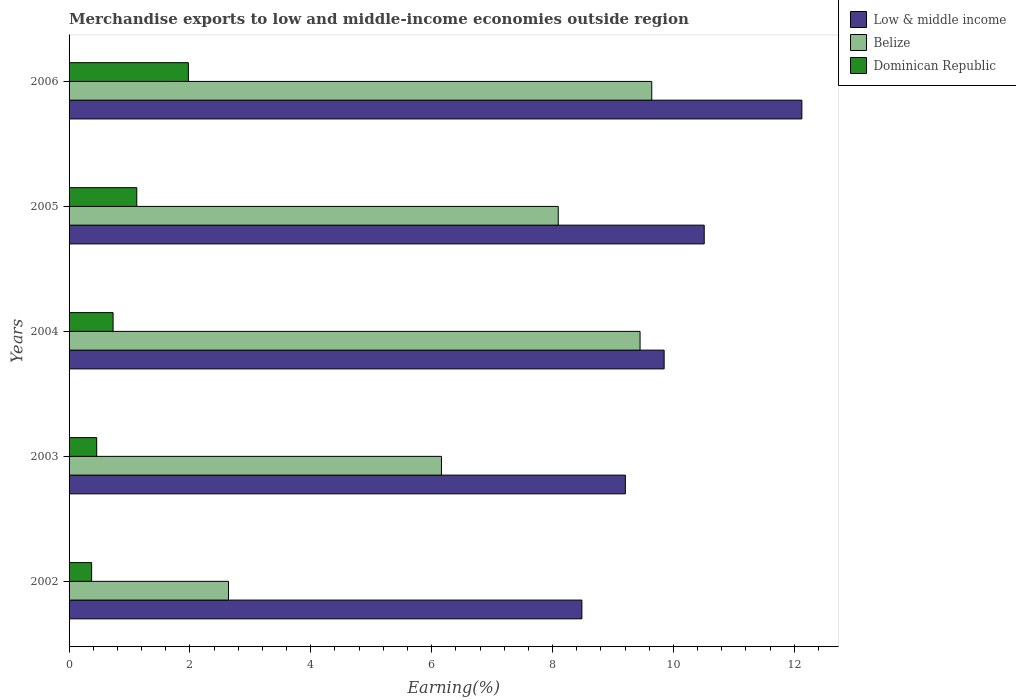Are the number of bars on each tick of the Y-axis equal?
Your answer should be very brief. Yes. How many bars are there on the 4th tick from the bottom?
Your answer should be very brief. 3. What is the label of the 3rd group of bars from the top?
Your answer should be very brief. 2004. In how many cases, is the number of bars for a given year not equal to the number of legend labels?
Keep it short and to the point. 0. What is the percentage of amount earned from merchandise exports in Belize in 2004?
Your response must be concise. 9.45. Across all years, what is the maximum percentage of amount earned from merchandise exports in Belize?
Your answer should be very brief. 9.64. Across all years, what is the minimum percentage of amount earned from merchandise exports in Low & middle income?
Ensure brevity in your answer.  8.49. In which year was the percentage of amount earned from merchandise exports in Dominican Republic maximum?
Provide a short and direct response. 2006. In which year was the percentage of amount earned from merchandise exports in Dominican Republic minimum?
Provide a succinct answer. 2002. What is the total percentage of amount earned from merchandise exports in Low & middle income in the graph?
Keep it short and to the point. 50.17. What is the difference between the percentage of amount earned from merchandise exports in Low & middle income in 2002 and that in 2006?
Offer a very short reply. -3.64. What is the difference between the percentage of amount earned from merchandise exports in Low & middle income in 2006 and the percentage of amount earned from merchandise exports in Dominican Republic in 2002?
Ensure brevity in your answer.  11.75. What is the average percentage of amount earned from merchandise exports in Dominican Republic per year?
Make the answer very short. 0.93. In the year 2005, what is the difference between the percentage of amount earned from merchandise exports in Low & middle income and percentage of amount earned from merchandise exports in Dominican Republic?
Provide a short and direct response. 9.39. In how many years, is the percentage of amount earned from merchandise exports in Belize greater than 9.6 %?
Ensure brevity in your answer.  1. What is the ratio of the percentage of amount earned from merchandise exports in Dominican Republic in 2005 to that in 2006?
Your response must be concise. 0.57. What is the difference between the highest and the second highest percentage of amount earned from merchandise exports in Dominican Republic?
Offer a very short reply. 0.85. What is the difference between the highest and the lowest percentage of amount earned from merchandise exports in Dominican Republic?
Offer a terse response. 1.6. What does the 1st bar from the top in 2003 represents?
Your response must be concise. Dominican Republic. What does the 3rd bar from the bottom in 2002 represents?
Provide a succinct answer. Dominican Republic. How many bars are there?
Provide a succinct answer. 15. How many years are there in the graph?
Offer a very short reply. 5. What is the difference between two consecutive major ticks on the X-axis?
Your response must be concise. 2. Does the graph contain grids?
Your answer should be very brief. No. How are the legend labels stacked?
Give a very brief answer. Vertical. What is the title of the graph?
Your answer should be compact. Merchandise exports to low and middle-income economies outside region. What is the label or title of the X-axis?
Your answer should be very brief. Earning(%). What is the label or title of the Y-axis?
Provide a short and direct response. Years. What is the Earning(%) of Low & middle income in 2002?
Offer a very short reply. 8.49. What is the Earning(%) in Belize in 2002?
Offer a very short reply. 2.64. What is the Earning(%) of Dominican Republic in 2002?
Your answer should be very brief. 0.37. What is the Earning(%) in Low & middle income in 2003?
Make the answer very short. 9.2. What is the Earning(%) in Belize in 2003?
Your answer should be very brief. 6.16. What is the Earning(%) of Dominican Republic in 2003?
Make the answer very short. 0.46. What is the Earning(%) in Low & middle income in 2004?
Your answer should be very brief. 9.85. What is the Earning(%) of Belize in 2004?
Your response must be concise. 9.45. What is the Earning(%) in Dominican Republic in 2004?
Make the answer very short. 0.73. What is the Earning(%) of Low & middle income in 2005?
Ensure brevity in your answer.  10.51. What is the Earning(%) in Belize in 2005?
Provide a short and direct response. 8.09. What is the Earning(%) of Dominican Republic in 2005?
Give a very brief answer. 1.12. What is the Earning(%) of Low & middle income in 2006?
Your answer should be very brief. 12.13. What is the Earning(%) in Belize in 2006?
Keep it short and to the point. 9.64. What is the Earning(%) in Dominican Republic in 2006?
Offer a terse response. 1.97. Across all years, what is the maximum Earning(%) in Low & middle income?
Your response must be concise. 12.13. Across all years, what is the maximum Earning(%) in Belize?
Ensure brevity in your answer.  9.64. Across all years, what is the maximum Earning(%) in Dominican Republic?
Provide a succinct answer. 1.97. Across all years, what is the minimum Earning(%) in Low & middle income?
Keep it short and to the point. 8.49. Across all years, what is the minimum Earning(%) of Belize?
Provide a succinct answer. 2.64. Across all years, what is the minimum Earning(%) in Dominican Republic?
Give a very brief answer. 0.37. What is the total Earning(%) of Low & middle income in the graph?
Ensure brevity in your answer.  50.17. What is the total Earning(%) of Belize in the graph?
Offer a terse response. 35.98. What is the total Earning(%) in Dominican Republic in the graph?
Give a very brief answer. 4.65. What is the difference between the Earning(%) of Low & middle income in 2002 and that in 2003?
Give a very brief answer. -0.72. What is the difference between the Earning(%) in Belize in 2002 and that in 2003?
Offer a very short reply. -3.52. What is the difference between the Earning(%) in Dominican Republic in 2002 and that in 2003?
Your answer should be compact. -0.08. What is the difference between the Earning(%) in Low & middle income in 2002 and that in 2004?
Keep it short and to the point. -1.36. What is the difference between the Earning(%) in Belize in 2002 and that in 2004?
Make the answer very short. -6.81. What is the difference between the Earning(%) of Dominican Republic in 2002 and that in 2004?
Your answer should be compact. -0.35. What is the difference between the Earning(%) in Low & middle income in 2002 and that in 2005?
Provide a short and direct response. -2.02. What is the difference between the Earning(%) in Belize in 2002 and that in 2005?
Make the answer very short. -5.46. What is the difference between the Earning(%) in Dominican Republic in 2002 and that in 2005?
Make the answer very short. -0.75. What is the difference between the Earning(%) in Low & middle income in 2002 and that in 2006?
Your answer should be very brief. -3.64. What is the difference between the Earning(%) in Belize in 2002 and that in 2006?
Provide a short and direct response. -7. What is the difference between the Earning(%) in Dominican Republic in 2002 and that in 2006?
Make the answer very short. -1.6. What is the difference between the Earning(%) in Low & middle income in 2003 and that in 2004?
Ensure brevity in your answer.  -0.64. What is the difference between the Earning(%) of Belize in 2003 and that in 2004?
Make the answer very short. -3.29. What is the difference between the Earning(%) of Dominican Republic in 2003 and that in 2004?
Offer a terse response. -0.27. What is the difference between the Earning(%) in Low & middle income in 2003 and that in 2005?
Give a very brief answer. -1.3. What is the difference between the Earning(%) in Belize in 2003 and that in 2005?
Offer a very short reply. -1.93. What is the difference between the Earning(%) of Dominican Republic in 2003 and that in 2005?
Make the answer very short. -0.66. What is the difference between the Earning(%) of Low & middle income in 2003 and that in 2006?
Offer a terse response. -2.92. What is the difference between the Earning(%) in Belize in 2003 and that in 2006?
Provide a succinct answer. -3.48. What is the difference between the Earning(%) of Dominican Republic in 2003 and that in 2006?
Give a very brief answer. -1.52. What is the difference between the Earning(%) of Low & middle income in 2004 and that in 2005?
Ensure brevity in your answer.  -0.66. What is the difference between the Earning(%) of Belize in 2004 and that in 2005?
Offer a very short reply. 1.35. What is the difference between the Earning(%) of Dominican Republic in 2004 and that in 2005?
Offer a terse response. -0.39. What is the difference between the Earning(%) of Low & middle income in 2004 and that in 2006?
Offer a very short reply. -2.28. What is the difference between the Earning(%) of Belize in 2004 and that in 2006?
Give a very brief answer. -0.19. What is the difference between the Earning(%) in Dominican Republic in 2004 and that in 2006?
Make the answer very short. -1.25. What is the difference between the Earning(%) in Low & middle income in 2005 and that in 2006?
Keep it short and to the point. -1.62. What is the difference between the Earning(%) in Belize in 2005 and that in 2006?
Offer a very short reply. -1.55. What is the difference between the Earning(%) of Dominican Republic in 2005 and that in 2006?
Give a very brief answer. -0.85. What is the difference between the Earning(%) in Low & middle income in 2002 and the Earning(%) in Belize in 2003?
Your answer should be very brief. 2.32. What is the difference between the Earning(%) of Low & middle income in 2002 and the Earning(%) of Dominican Republic in 2003?
Provide a short and direct response. 8.03. What is the difference between the Earning(%) of Belize in 2002 and the Earning(%) of Dominican Republic in 2003?
Offer a very short reply. 2.18. What is the difference between the Earning(%) of Low & middle income in 2002 and the Earning(%) of Belize in 2004?
Make the answer very short. -0.96. What is the difference between the Earning(%) in Low & middle income in 2002 and the Earning(%) in Dominican Republic in 2004?
Your answer should be compact. 7.76. What is the difference between the Earning(%) in Belize in 2002 and the Earning(%) in Dominican Republic in 2004?
Your response must be concise. 1.91. What is the difference between the Earning(%) in Low & middle income in 2002 and the Earning(%) in Belize in 2005?
Keep it short and to the point. 0.39. What is the difference between the Earning(%) of Low & middle income in 2002 and the Earning(%) of Dominican Republic in 2005?
Your answer should be very brief. 7.37. What is the difference between the Earning(%) in Belize in 2002 and the Earning(%) in Dominican Republic in 2005?
Keep it short and to the point. 1.52. What is the difference between the Earning(%) of Low & middle income in 2002 and the Earning(%) of Belize in 2006?
Ensure brevity in your answer.  -1.16. What is the difference between the Earning(%) of Low & middle income in 2002 and the Earning(%) of Dominican Republic in 2006?
Make the answer very short. 6.51. What is the difference between the Earning(%) of Belize in 2002 and the Earning(%) of Dominican Republic in 2006?
Ensure brevity in your answer.  0.66. What is the difference between the Earning(%) in Low & middle income in 2003 and the Earning(%) in Belize in 2004?
Your response must be concise. -0.24. What is the difference between the Earning(%) of Low & middle income in 2003 and the Earning(%) of Dominican Republic in 2004?
Provide a short and direct response. 8.48. What is the difference between the Earning(%) of Belize in 2003 and the Earning(%) of Dominican Republic in 2004?
Offer a very short reply. 5.43. What is the difference between the Earning(%) of Low & middle income in 2003 and the Earning(%) of Belize in 2005?
Your answer should be very brief. 1.11. What is the difference between the Earning(%) in Low & middle income in 2003 and the Earning(%) in Dominican Republic in 2005?
Your answer should be compact. 8.08. What is the difference between the Earning(%) of Belize in 2003 and the Earning(%) of Dominican Republic in 2005?
Your response must be concise. 5.04. What is the difference between the Earning(%) in Low & middle income in 2003 and the Earning(%) in Belize in 2006?
Ensure brevity in your answer.  -0.44. What is the difference between the Earning(%) in Low & middle income in 2003 and the Earning(%) in Dominican Republic in 2006?
Make the answer very short. 7.23. What is the difference between the Earning(%) in Belize in 2003 and the Earning(%) in Dominican Republic in 2006?
Give a very brief answer. 4.19. What is the difference between the Earning(%) in Low & middle income in 2004 and the Earning(%) in Belize in 2005?
Keep it short and to the point. 1.75. What is the difference between the Earning(%) in Low & middle income in 2004 and the Earning(%) in Dominican Republic in 2005?
Make the answer very short. 8.73. What is the difference between the Earning(%) of Belize in 2004 and the Earning(%) of Dominican Republic in 2005?
Your answer should be compact. 8.33. What is the difference between the Earning(%) in Low & middle income in 2004 and the Earning(%) in Belize in 2006?
Your answer should be very brief. 0.2. What is the difference between the Earning(%) of Low & middle income in 2004 and the Earning(%) of Dominican Republic in 2006?
Provide a short and direct response. 7.87. What is the difference between the Earning(%) of Belize in 2004 and the Earning(%) of Dominican Republic in 2006?
Provide a short and direct response. 7.47. What is the difference between the Earning(%) of Low & middle income in 2005 and the Earning(%) of Belize in 2006?
Offer a terse response. 0.87. What is the difference between the Earning(%) in Low & middle income in 2005 and the Earning(%) in Dominican Republic in 2006?
Ensure brevity in your answer.  8.54. What is the difference between the Earning(%) of Belize in 2005 and the Earning(%) of Dominican Republic in 2006?
Ensure brevity in your answer.  6.12. What is the average Earning(%) in Low & middle income per year?
Keep it short and to the point. 10.03. What is the average Earning(%) of Belize per year?
Offer a very short reply. 7.2. What is the average Earning(%) of Dominican Republic per year?
Make the answer very short. 0.93. In the year 2002, what is the difference between the Earning(%) in Low & middle income and Earning(%) in Belize?
Provide a succinct answer. 5.85. In the year 2002, what is the difference between the Earning(%) in Low & middle income and Earning(%) in Dominican Republic?
Give a very brief answer. 8.11. In the year 2002, what is the difference between the Earning(%) in Belize and Earning(%) in Dominican Republic?
Your answer should be compact. 2.26. In the year 2003, what is the difference between the Earning(%) in Low & middle income and Earning(%) in Belize?
Offer a very short reply. 3.04. In the year 2003, what is the difference between the Earning(%) in Low & middle income and Earning(%) in Dominican Republic?
Give a very brief answer. 8.75. In the year 2003, what is the difference between the Earning(%) in Belize and Earning(%) in Dominican Republic?
Make the answer very short. 5.7. In the year 2004, what is the difference between the Earning(%) of Low & middle income and Earning(%) of Belize?
Give a very brief answer. 0.4. In the year 2004, what is the difference between the Earning(%) of Low & middle income and Earning(%) of Dominican Republic?
Ensure brevity in your answer.  9.12. In the year 2004, what is the difference between the Earning(%) in Belize and Earning(%) in Dominican Republic?
Ensure brevity in your answer.  8.72. In the year 2005, what is the difference between the Earning(%) in Low & middle income and Earning(%) in Belize?
Keep it short and to the point. 2.42. In the year 2005, what is the difference between the Earning(%) in Low & middle income and Earning(%) in Dominican Republic?
Your answer should be very brief. 9.39. In the year 2005, what is the difference between the Earning(%) in Belize and Earning(%) in Dominican Republic?
Keep it short and to the point. 6.97. In the year 2006, what is the difference between the Earning(%) in Low & middle income and Earning(%) in Belize?
Ensure brevity in your answer.  2.48. In the year 2006, what is the difference between the Earning(%) of Low & middle income and Earning(%) of Dominican Republic?
Keep it short and to the point. 10.15. In the year 2006, what is the difference between the Earning(%) of Belize and Earning(%) of Dominican Republic?
Your answer should be compact. 7.67. What is the ratio of the Earning(%) of Low & middle income in 2002 to that in 2003?
Your answer should be very brief. 0.92. What is the ratio of the Earning(%) of Belize in 2002 to that in 2003?
Give a very brief answer. 0.43. What is the ratio of the Earning(%) in Dominican Republic in 2002 to that in 2003?
Keep it short and to the point. 0.82. What is the ratio of the Earning(%) in Low & middle income in 2002 to that in 2004?
Provide a succinct answer. 0.86. What is the ratio of the Earning(%) in Belize in 2002 to that in 2004?
Provide a short and direct response. 0.28. What is the ratio of the Earning(%) in Dominican Republic in 2002 to that in 2004?
Provide a succinct answer. 0.51. What is the ratio of the Earning(%) in Low & middle income in 2002 to that in 2005?
Provide a succinct answer. 0.81. What is the ratio of the Earning(%) of Belize in 2002 to that in 2005?
Your answer should be compact. 0.33. What is the ratio of the Earning(%) of Low & middle income in 2002 to that in 2006?
Make the answer very short. 0.7. What is the ratio of the Earning(%) of Belize in 2002 to that in 2006?
Offer a terse response. 0.27. What is the ratio of the Earning(%) of Dominican Republic in 2002 to that in 2006?
Provide a succinct answer. 0.19. What is the ratio of the Earning(%) of Low & middle income in 2003 to that in 2004?
Offer a terse response. 0.93. What is the ratio of the Earning(%) in Belize in 2003 to that in 2004?
Give a very brief answer. 0.65. What is the ratio of the Earning(%) of Dominican Republic in 2003 to that in 2004?
Offer a very short reply. 0.63. What is the ratio of the Earning(%) in Low & middle income in 2003 to that in 2005?
Your answer should be compact. 0.88. What is the ratio of the Earning(%) of Belize in 2003 to that in 2005?
Give a very brief answer. 0.76. What is the ratio of the Earning(%) in Dominican Republic in 2003 to that in 2005?
Your response must be concise. 0.41. What is the ratio of the Earning(%) in Low & middle income in 2003 to that in 2006?
Keep it short and to the point. 0.76. What is the ratio of the Earning(%) of Belize in 2003 to that in 2006?
Your response must be concise. 0.64. What is the ratio of the Earning(%) in Dominican Republic in 2003 to that in 2006?
Your answer should be compact. 0.23. What is the ratio of the Earning(%) in Low & middle income in 2004 to that in 2005?
Offer a very short reply. 0.94. What is the ratio of the Earning(%) in Belize in 2004 to that in 2005?
Keep it short and to the point. 1.17. What is the ratio of the Earning(%) of Dominican Republic in 2004 to that in 2005?
Offer a very short reply. 0.65. What is the ratio of the Earning(%) of Low & middle income in 2004 to that in 2006?
Keep it short and to the point. 0.81. What is the ratio of the Earning(%) of Belize in 2004 to that in 2006?
Make the answer very short. 0.98. What is the ratio of the Earning(%) in Dominican Republic in 2004 to that in 2006?
Provide a short and direct response. 0.37. What is the ratio of the Earning(%) of Low & middle income in 2005 to that in 2006?
Provide a succinct answer. 0.87. What is the ratio of the Earning(%) in Belize in 2005 to that in 2006?
Offer a terse response. 0.84. What is the ratio of the Earning(%) of Dominican Republic in 2005 to that in 2006?
Provide a succinct answer. 0.57. What is the difference between the highest and the second highest Earning(%) in Low & middle income?
Your response must be concise. 1.62. What is the difference between the highest and the second highest Earning(%) in Belize?
Offer a very short reply. 0.19. What is the difference between the highest and the second highest Earning(%) in Dominican Republic?
Your response must be concise. 0.85. What is the difference between the highest and the lowest Earning(%) in Low & middle income?
Your response must be concise. 3.64. What is the difference between the highest and the lowest Earning(%) of Belize?
Make the answer very short. 7. What is the difference between the highest and the lowest Earning(%) in Dominican Republic?
Keep it short and to the point. 1.6. 